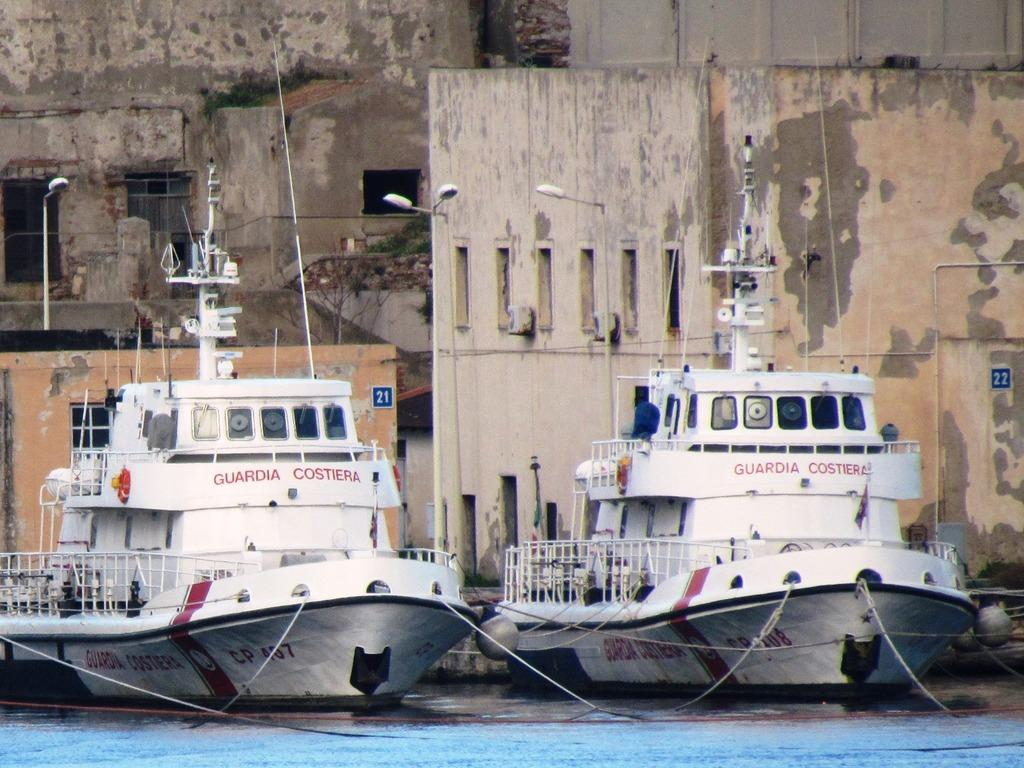What is located above the water in the image? There are ships above the water in the image. What objects can be seen in the image besides the ships? There are poles and lights visible in the image. What can be seen in the background of the image? There are buildings and a tree in the background of the image. What type of pleasure can be seen enjoying the orange in the image? There is no pleasure or orange present in the image; it features ships, poles, lights, buildings, and a tree. What type of quartz is used to illuminate the poles in the image? There is no mention of quartz or any specific type of lighting source in the image; it only shows lights on poles. 